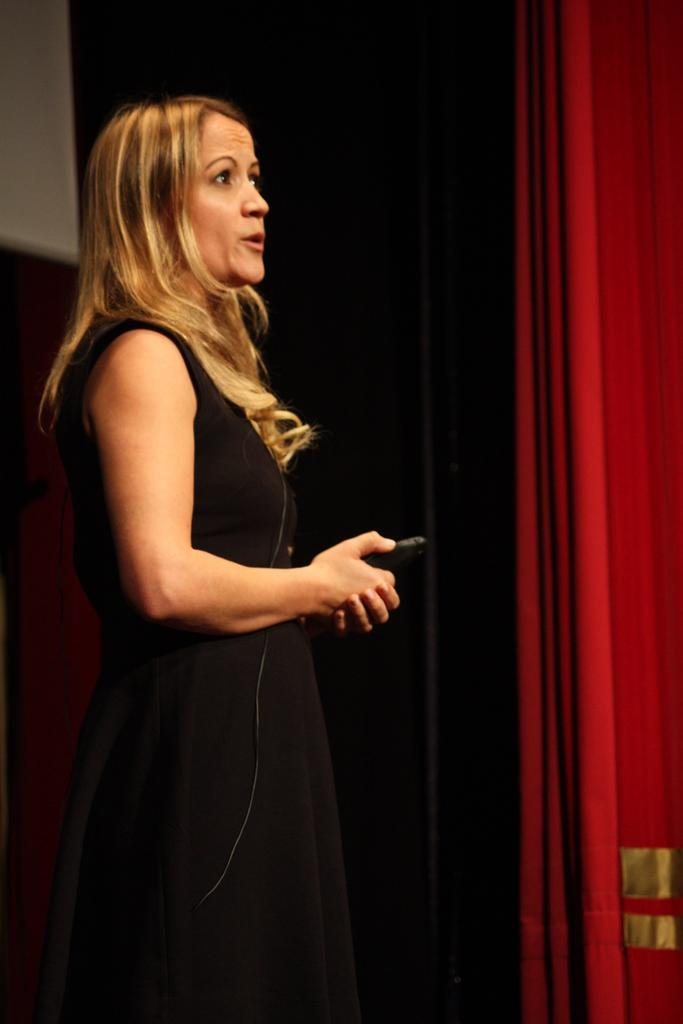Who is present in the image? There is a woman in the image. What is the woman wearing? The woman is wearing a black dress. What object is the woman holding? The woman is holding a mobile phone. What can be seen in the background of the image? There is a red color curtain in the background of the image. What type of ornament is the woman wearing around her neck in the image? There is no ornament visible around the woman's neck in the image. 